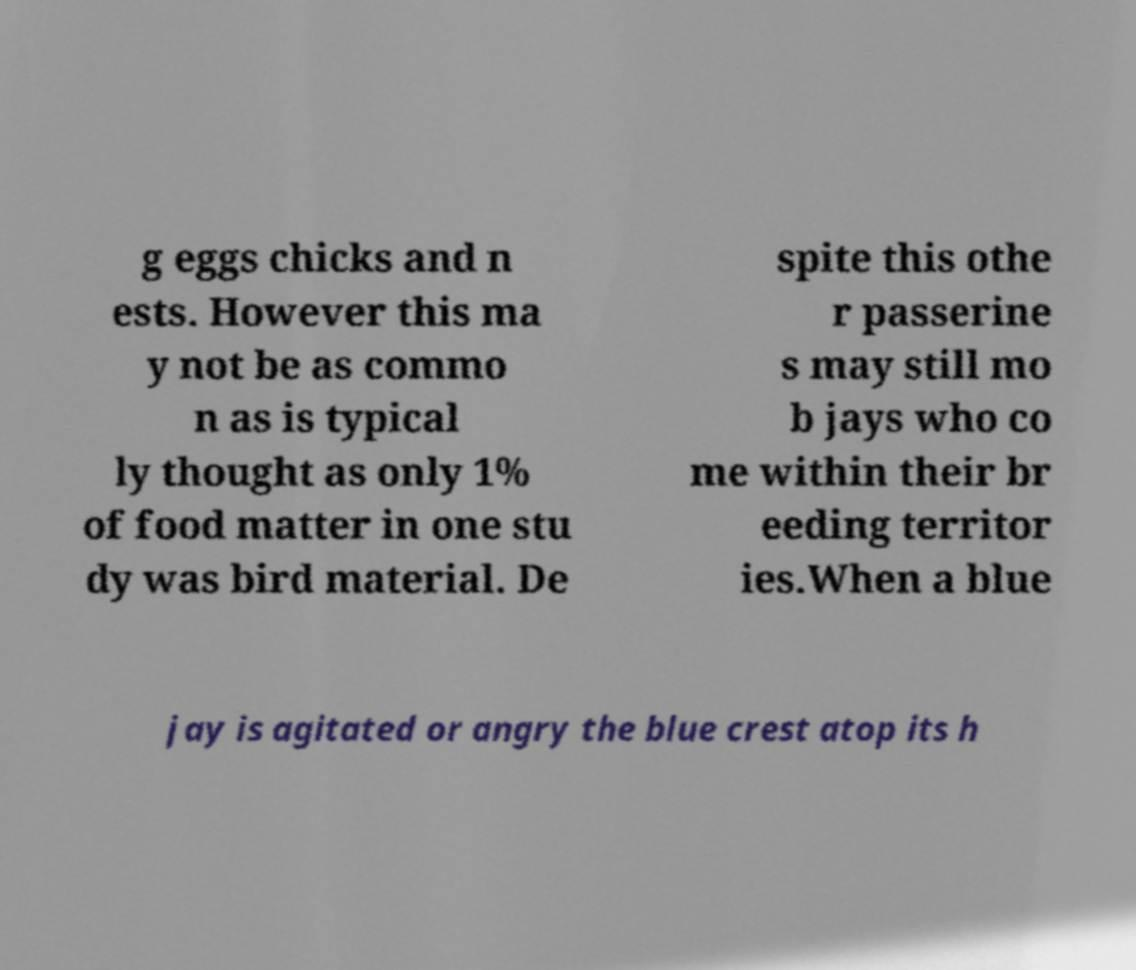For documentation purposes, I need the text within this image transcribed. Could you provide that? g eggs chicks and n ests. However this ma y not be as commo n as is typical ly thought as only 1% of food matter in one stu dy was bird material. De spite this othe r passerine s may still mo b jays who co me within their br eeding territor ies.When a blue jay is agitated or angry the blue crest atop its h 